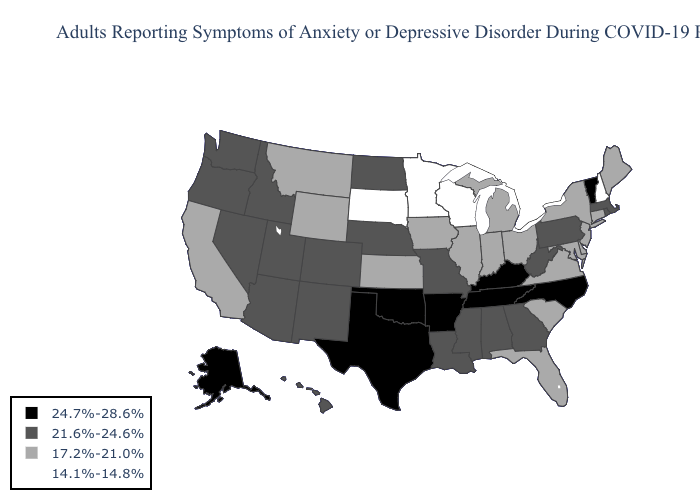Name the states that have a value in the range 21.6%-24.6%?
Be succinct. Alabama, Arizona, Colorado, Georgia, Hawaii, Idaho, Louisiana, Massachusetts, Mississippi, Missouri, Nebraska, Nevada, New Mexico, North Dakota, Oregon, Pennsylvania, Rhode Island, Utah, Washington, West Virginia. What is the value of Minnesota?
Keep it brief. 14.1%-14.8%. Does Nebraska have the highest value in the USA?
Write a very short answer. No. Does the first symbol in the legend represent the smallest category?
Short answer required. No. What is the highest value in the West ?
Write a very short answer. 24.7%-28.6%. Name the states that have a value in the range 14.1%-14.8%?
Short answer required. Minnesota, New Hampshire, South Dakota, Wisconsin. Does Virginia have a higher value than Connecticut?
Concise answer only. No. Name the states that have a value in the range 24.7%-28.6%?
Keep it brief. Alaska, Arkansas, Kentucky, North Carolina, Oklahoma, Tennessee, Texas, Vermont. Among the states that border Illinois , does Wisconsin have the highest value?
Short answer required. No. How many symbols are there in the legend?
Give a very brief answer. 4. Is the legend a continuous bar?
Keep it brief. No. What is the highest value in the USA?
Short answer required. 24.7%-28.6%. Name the states that have a value in the range 14.1%-14.8%?
Answer briefly. Minnesota, New Hampshire, South Dakota, Wisconsin. What is the highest value in states that border New Jersey?
Keep it brief. 21.6%-24.6%. Name the states that have a value in the range 17.2%-21.0%?
Keep it brief. California, Connecticut, Delaware, Florida, Illinois, Indiana, Iowa, Kansas, Maine, Maryland, Michigan, Montana, New Jersey, New York, Ohio, South Carolina, Virginia, Wyoming. 